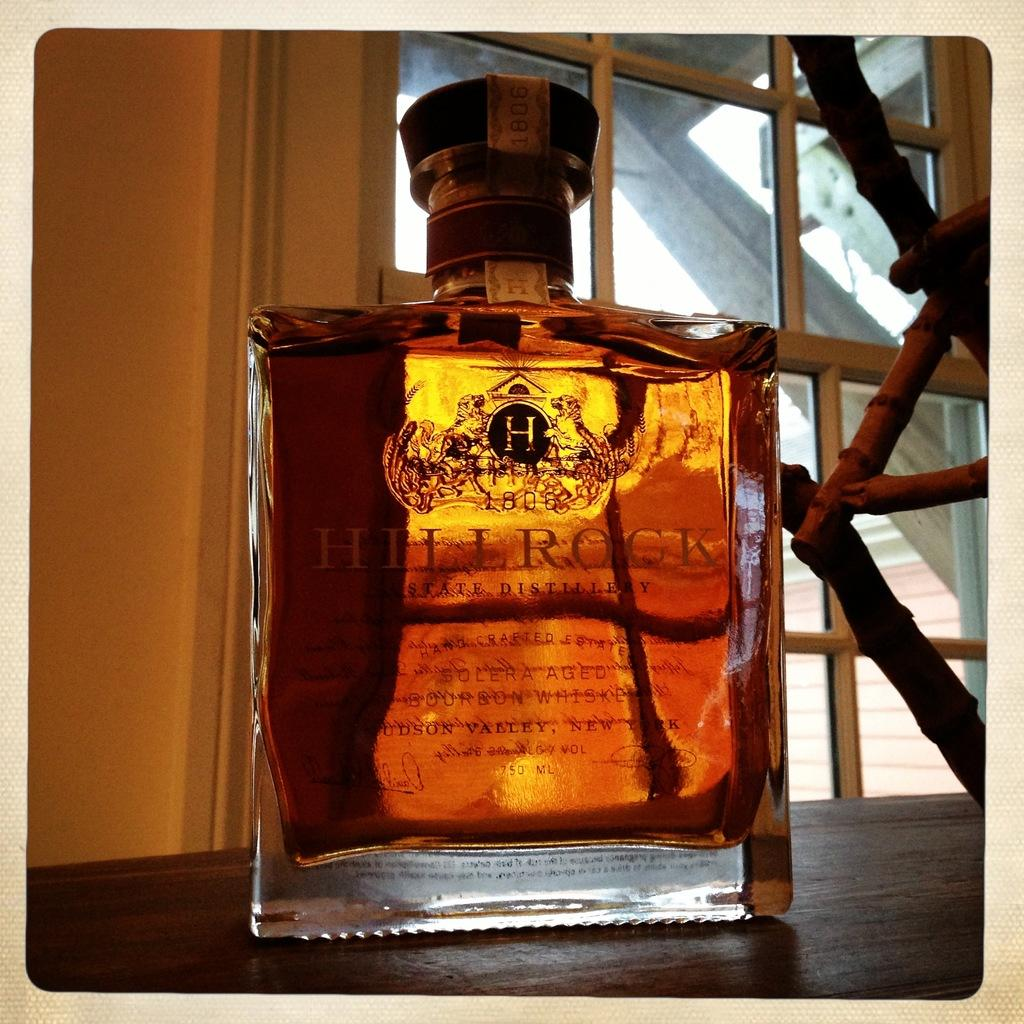<image>
Write a terse but informative summary of the picture. A full and sealed bottle of Hill Rock whiskey is on a wooden surface, by the entrance of a room. 